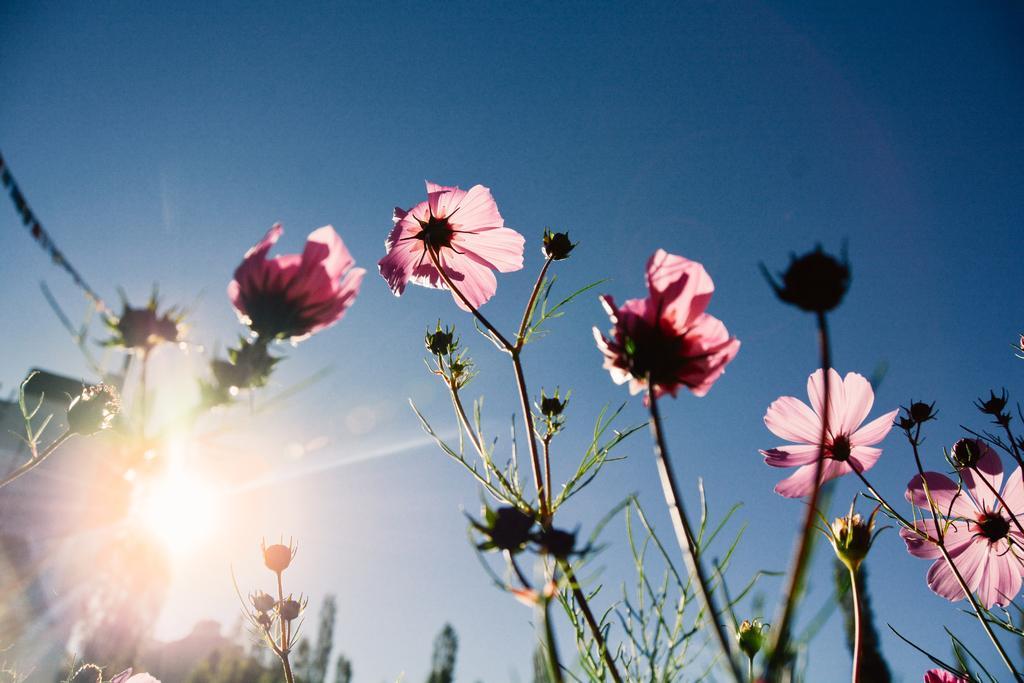How would you summarize this image in a sentence or two? There are plants having pink color flowers. In the background, there are trees, there is a sun and there is a blue sky. 